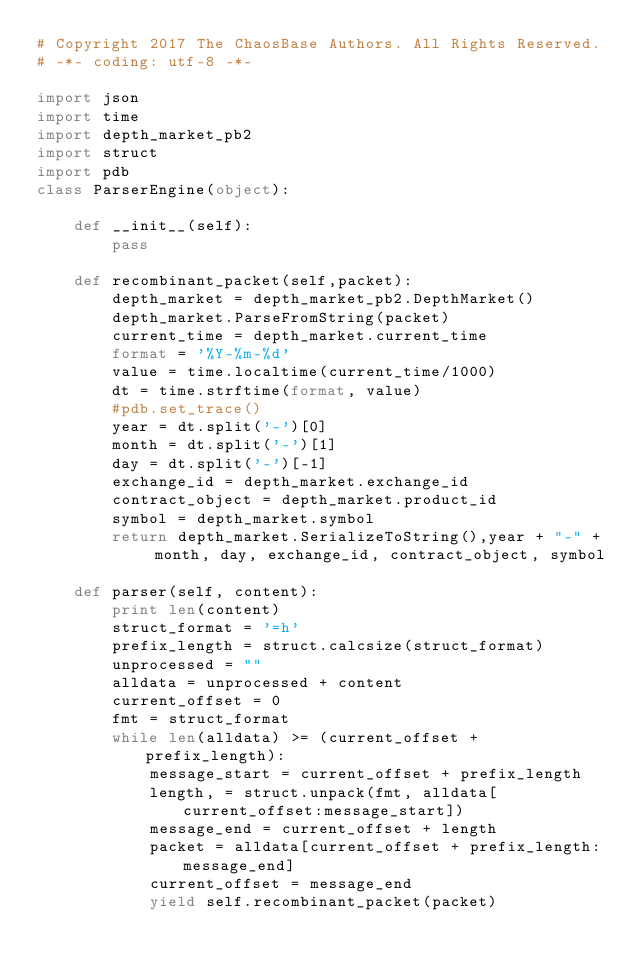Convert code to text. <code><loc_0><loc_0><loc_500><loc_500><_Python_># Copyright 2017 The ChaosBase Authors. All Rights Reserved.
# -*- coding: utf-8 -*-

import json
import time
import depth_market_pb2
import struct
import pdb
class ParserEngine(object):

    def __init__(self):
        pass

    def recombinant_packet(self,packet):
        depth_market = depth_market_pb2.DepthMarket()
        depth_market.ParseFromString(packet) 
        current_time = depth_market.current_time
        format = '%Y-%m-%d'
        value = time.localtime(current_time/1000)
        dt = time.strftime(format, value)
        #pdb.set_trace()
        year = dt.split('-')[0]
        month = dt.split('-')[1]
        day = dt.split('-')[-1]
        exchange_id = depth_market.exchange_id
        contract_object = depth_market.product_id
        symbol = depth_market.symbol
        return depth_market.SerializeToString(),year + "-" + month, day, exchange_id, contract_object, symbol
    
    def parser(self, content):
        print len(content)
        struct_format = '=h'
        prefix_length = struct.calcsize(struct_format)
        unprocessed = ""
        alldata = unprocessed + content
        current_offset = 0
        fmt = struct_format
        while len(alldata) >= (current_offset + prefix_length):
            message_start = current_offset + prefix_length
            length, = struct.unpack(fmt, alldata[current_offset:message_start])
            message_end = current_offset + length
            packet = alldata[current_offset + prefix_length:message_end]
            current_offset = message_end
            yield self.recombinant_packet(packet)
</code> 